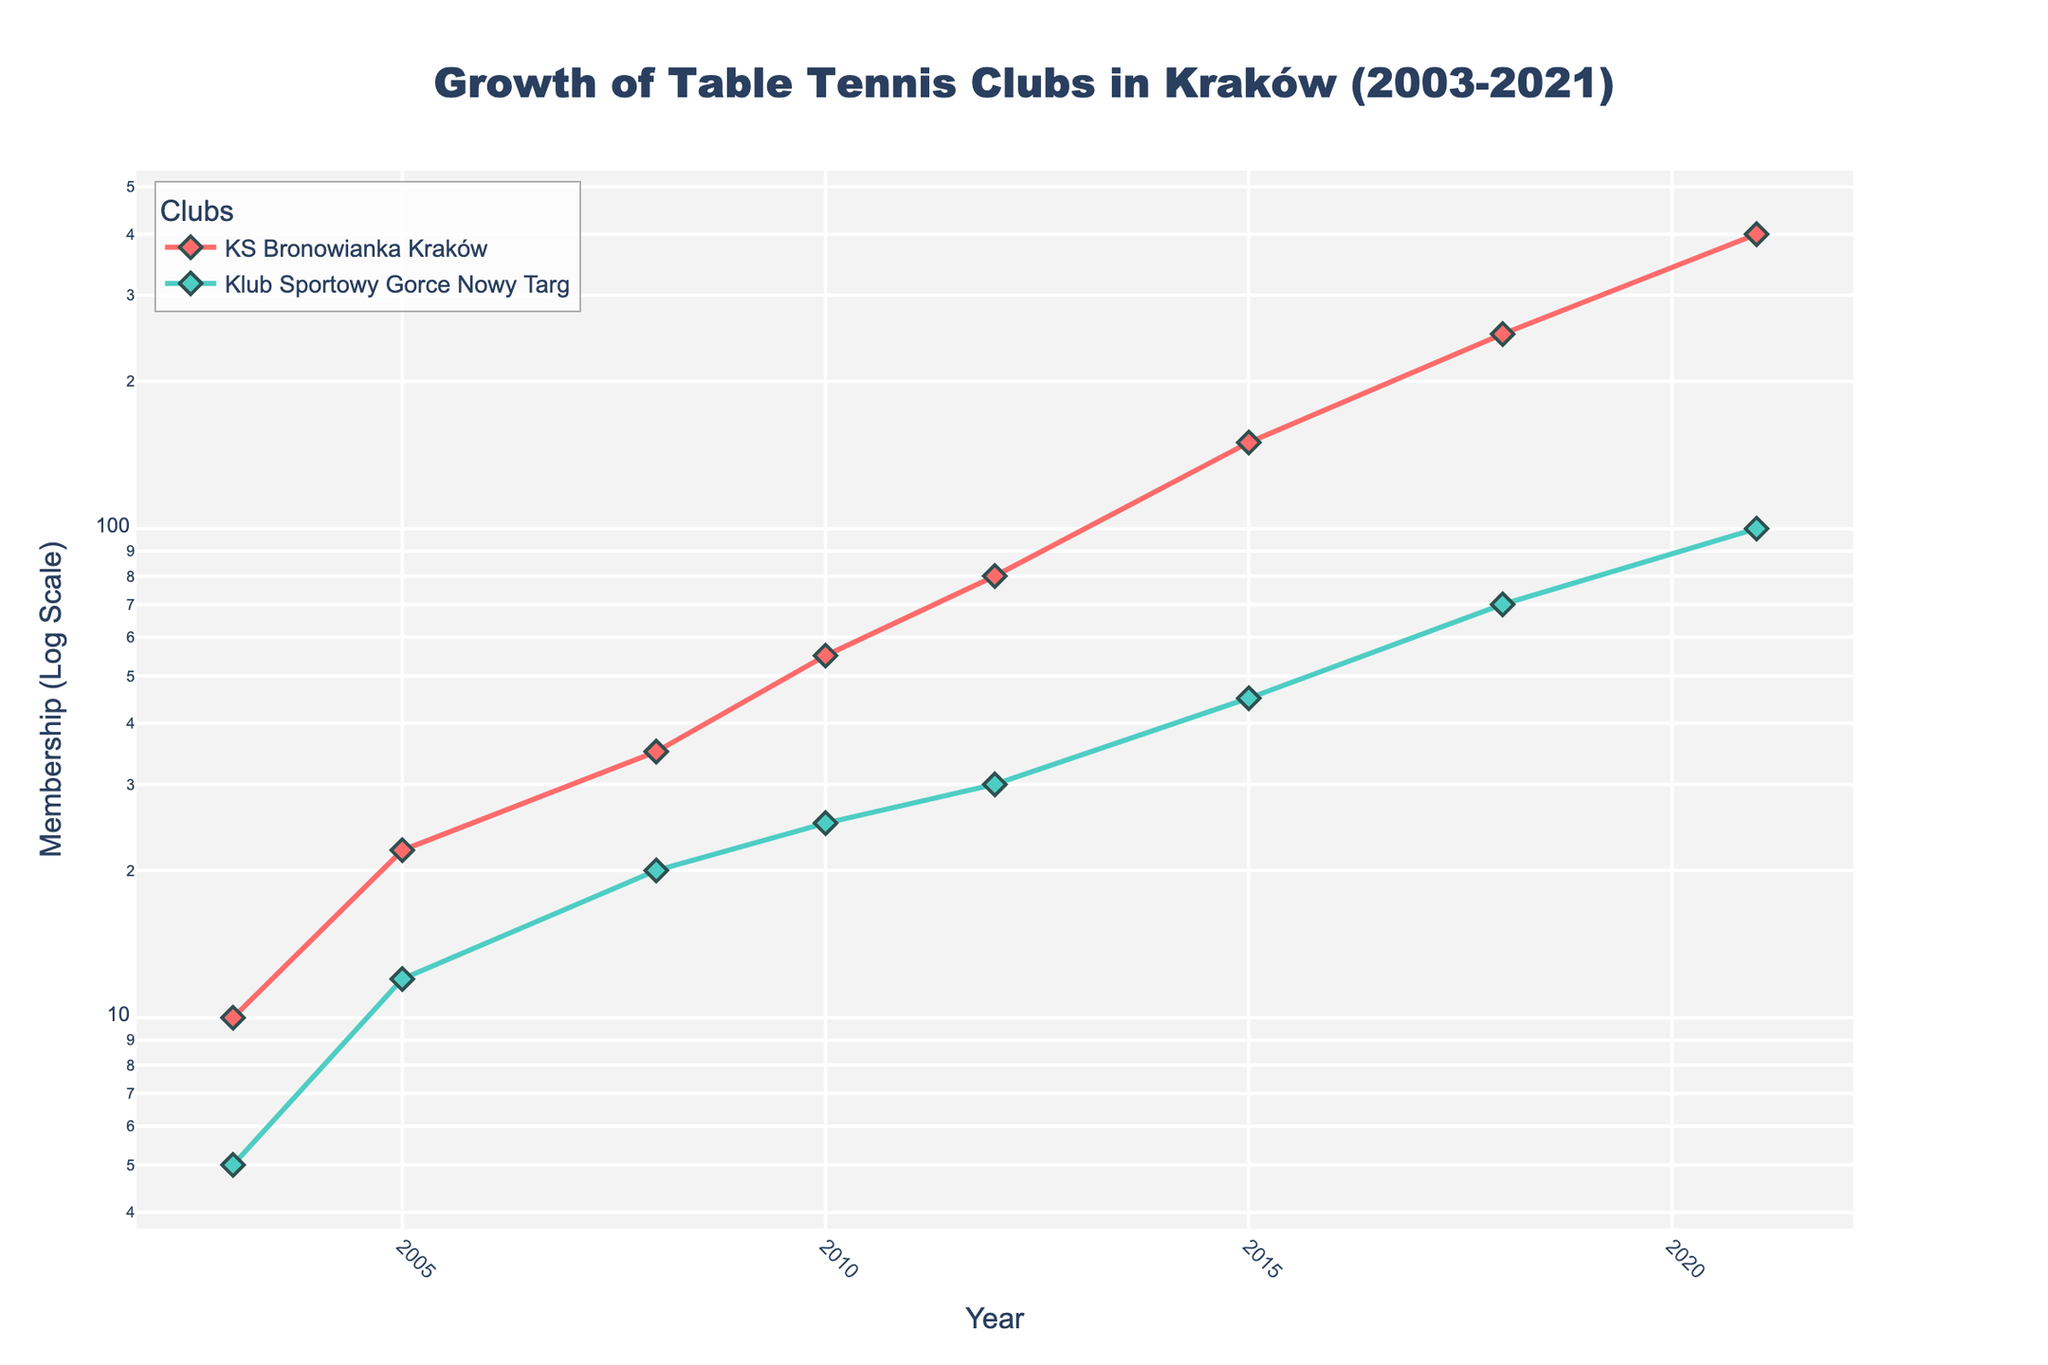What's the title of the plot? The title is displayed prominently at the top of the plot, it reads "Growth of Table Tennis Clubs in Kraków (2003-2021)".
Answer: Growth of Table Tennis Clubs in Kraków (2003-2021) Which club had higher membership in 2003? By examining the plot lines and markers for the year 2003, we can see that KS Bronowianka Kraków had 10 members and Klub Sportowy Gorce Nowy Targ had 5 members.
Answer: KS Bronowianka Kraków How does the membership number change for KS Bronowianka Kraków from 2015 to 2021? From 2015 to 2021, we follow the plot line for KS Bronowianka Kraków and see the membership grows from 150 to 400.
Answer: Increases What is the trend in membership for Klub Sportowy Gorce Nowy Targ from 2003 to 2021? Observing the plot for Klub Sportowy Gorce Nowy Targ over the years, we see a consistent upward trend in membership from 5 in 2003 to 100 in 2021.
Answer: Upward trend In which year did KS Bronowianka Kraków see a notable jump in its membership? The plot shows a noticeable increase in membership between 2012 and 2015 for KS Bronowianka Kraków, where the membership jumps from 80 to 150.
Answer: Between 2012 and 2015 Which club has a steeper rate of growth in membership between 2018 and 2021? Comparing the slope of the lines between 2018 and 2021, KS Bronowianka Kraków grows from 250 to 400, whereas Klub Sportowy Gorce Nowy Targ grows from 70 to 100. KS Bronowianka Kraków's line is steeper.
Answer: KS Bronowianka Kraków How many years did it take for KS Bronowianka Kraków to increase its membership from 10 to 100? By examining the plot, KS Bronowianka Kraków went from 10 members in 2003 to crossing the 100 mark around 2012, which is about 9 years.
Answer: About 9 years Describe the pattern of membership growth for Klub Sportowy Gorce Nowy Targ. Klub Sportowy Gorce Nowy Targ shows steady growth without drastic increases, starting from 5 in 2003 and reaching 100 in 2021. This pattern indicates gradual and consistent growth.
Answer: Steady and consistent growth What is the log-scale y-axis title of the plot? The y-axis title, indicated on the vertical axis of the plot, reads "Membership (Log Scale)".
Answer: Membership (Log Scale) How many distinct data points are plotted for KS Bronowianka Kraków? Analyzing the plot for KS Bronowianka Kraków, we can count the markers for each year, resulting in 8 distinct points (2003, 2005, 2008, 2010, 2012, 2015, 2018, 2021).
Answer: 8 